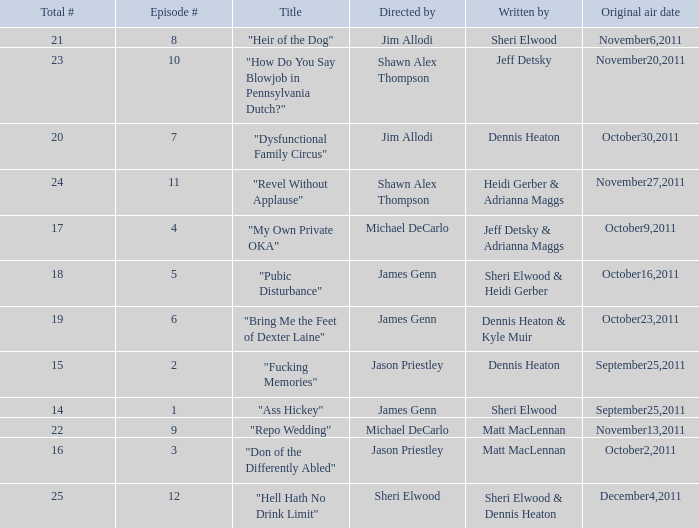Could you parse the entire table? {'header': ['Total #', 'Episode #', 'Title', 'Directed by', 'Written by', 'Original air date'], 'rows': [['21', '8', '"Heir of the Dog"', 'Jim Allodi', 'Sheri Elwood', 'November6,2011'], ['23', '10', '"How Do You Say Blowjob in Pennsylvania Dutch?"', 'Shawn Alex Thompson', 'Jeff Detsky', 'November20,2011'], ['20', '7', '"Dysfunctional Family Circus"', 'Jim Allodi', 'Dennis Heaton', 'October30,2011'], ['24', '11', '"Revel Without Applause"', 'Shawn Alex Thompson', 'Heidi Gerber & Adrianna Maggs', 'November27,2011'], ['17', '4', '"My Own Private OKA"', 'Michael DeCarlo', 'Jeff Detsky & Adrianna Maggs', 'October9,2011'], ['18', '5', '"Pubic Disturbance"', 'James Genn', 'Sheri Elwood & Heidi Gerber', 'October16,2011'], ['19', '6', '"Bring Me the Feet of Dexter Laine"', 'James Genn', 'Dennis Heaton & Kyle Muir', 'October23,2011'], ['15', '2', '"Fucking Memories"', 'Jason Priestley', 'Dennis Heaton', 'September25,2011'], ['14', '1', '"Ass Hickey"', 'James Genn', 'Sheri Elwood', 'September25,2011'], ['22', '9', '"Repo Wedding"', 'Michael DeCarlo', 'Matt MacLennan', 'November13,2011'], ['16', '3', '"Don of the Differently Abled"', 'Jason Priestley', 'Matt MacLennan', 'October2,2011'], ['25', '12', '"Hell Hath No Drink Limit"', 'Sheri Elwood', 'Sheri Elwood & Dennis Heaton', 'December4,2011']]} How many different episode numbers does the episode written by Sheri Elwood and directed by Jim Allodi have? 1.0. 